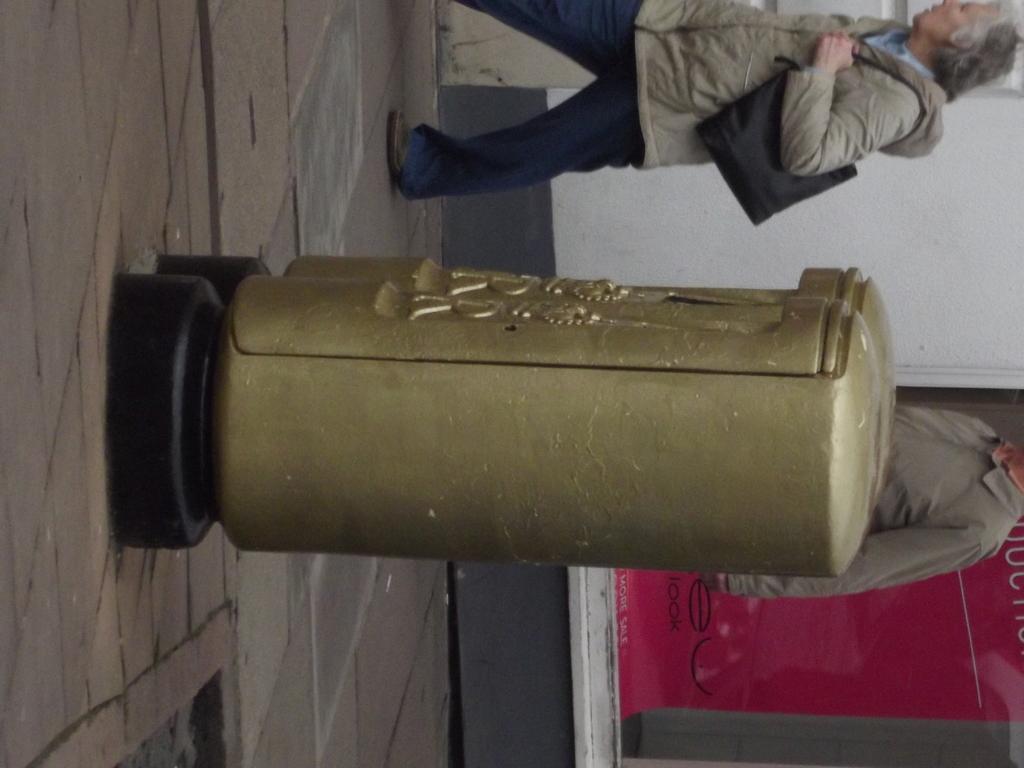Please provide a concise description of this image. In this picture there is a lady at the top side of the image and there are two golden color containers in the center of the image. 